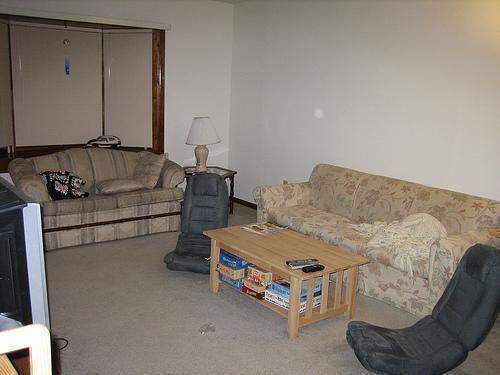How many coffee tables are visible?
Give a very brief answer. 1. How many lamps are visible in the photo?
Give a very brief answer. 1. How many couches are there?
Give a very brief answer. 2. 